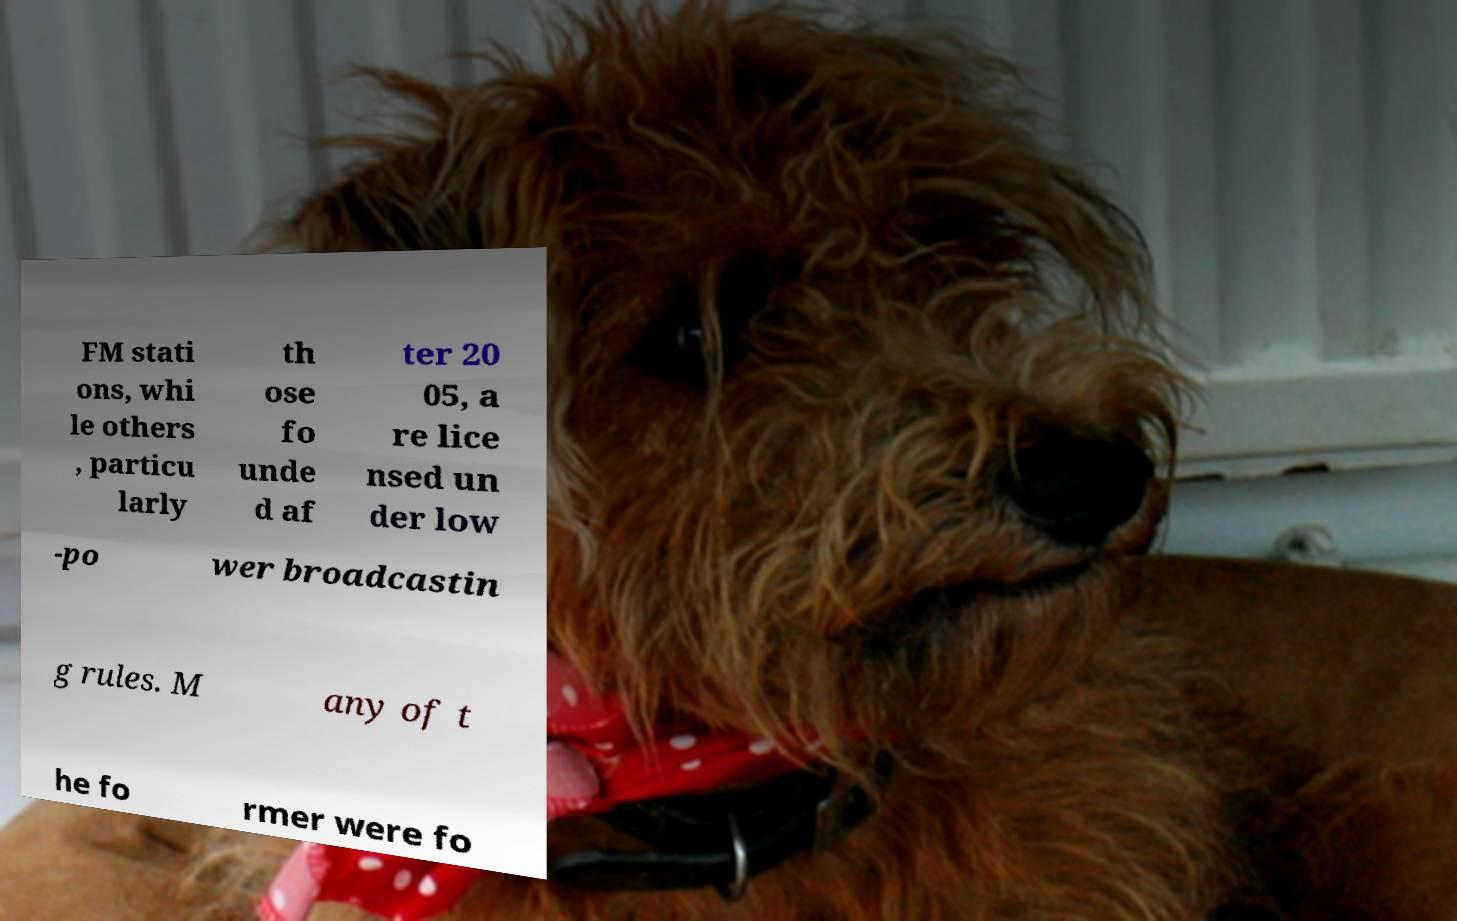I need the written content from this picture converted into text. Can you do that? FM stati ons, whi le others , particu larly th ose fo unde d af ter 20 05, a re lice nsed un der low -po wer broadcastin g rules. M any of t he fo rmer were fo 